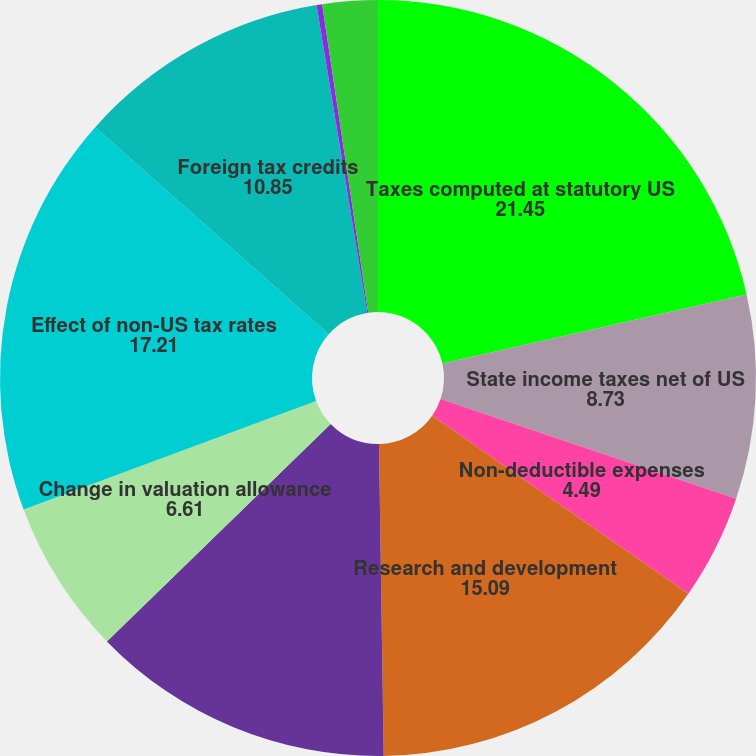Convert chart to OTSL. <chart><loc_0><loc_0><loc_500><loc_500><pie_chart><fcel>Taxes computed at statutory US<fcel>State income taxes net of US<fcel>Non-deductible expenses<fcel>Research and development<fcel>Tax effect of deemed dividends<fcel>Change in valuation allowance<fcel>Effect of non-US tax rates<fcel>Foreign tax credits<fcel>Stock-based compensation<fcel>Other<nl><fcel>21.45%<fcel>8.73%<fcel>4.49%<fcel>15.09%<fcel>12.97%<fcel>6.61%<fcel>17.21%<fcel>10.85%<fcel>0.24%<fcel>2.36%<nl></chart> 